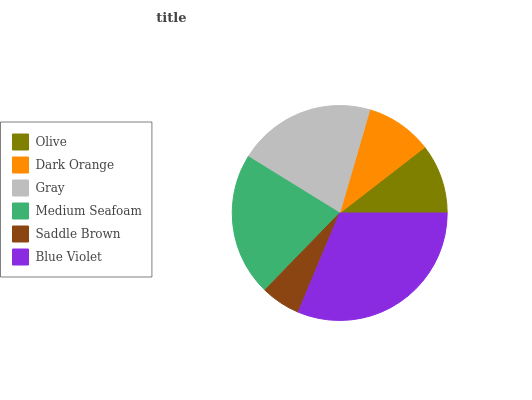Is Saddle Brown the minimum?
Answer yes or no. Yes. Is Blue Violet the maximum?
Answer yes or no. Yes. Is Dark Orange the minimum?
Answer yes or no. No. Is Dark Orange the maximum?
Answer yes or no. No. Is Olive greater than Dark Orange?
Answer yes or no. Yes. Is Dark Orange less than Olive?
Answer yes or no. Yes. Is Dark Orange greater than Olive?
Answer yes or no. No. Is Olive less than Dark Orange?
Answer yes or no. No. Is Gray the high median?
Answer yes or no. Yes. Is Olive the low median?
Answer yes or no. Yes. Is Medium Seafoam the high median?
Answer yes or no. No. Is Saddle Brown the low median?
Answer yes or no. No. 